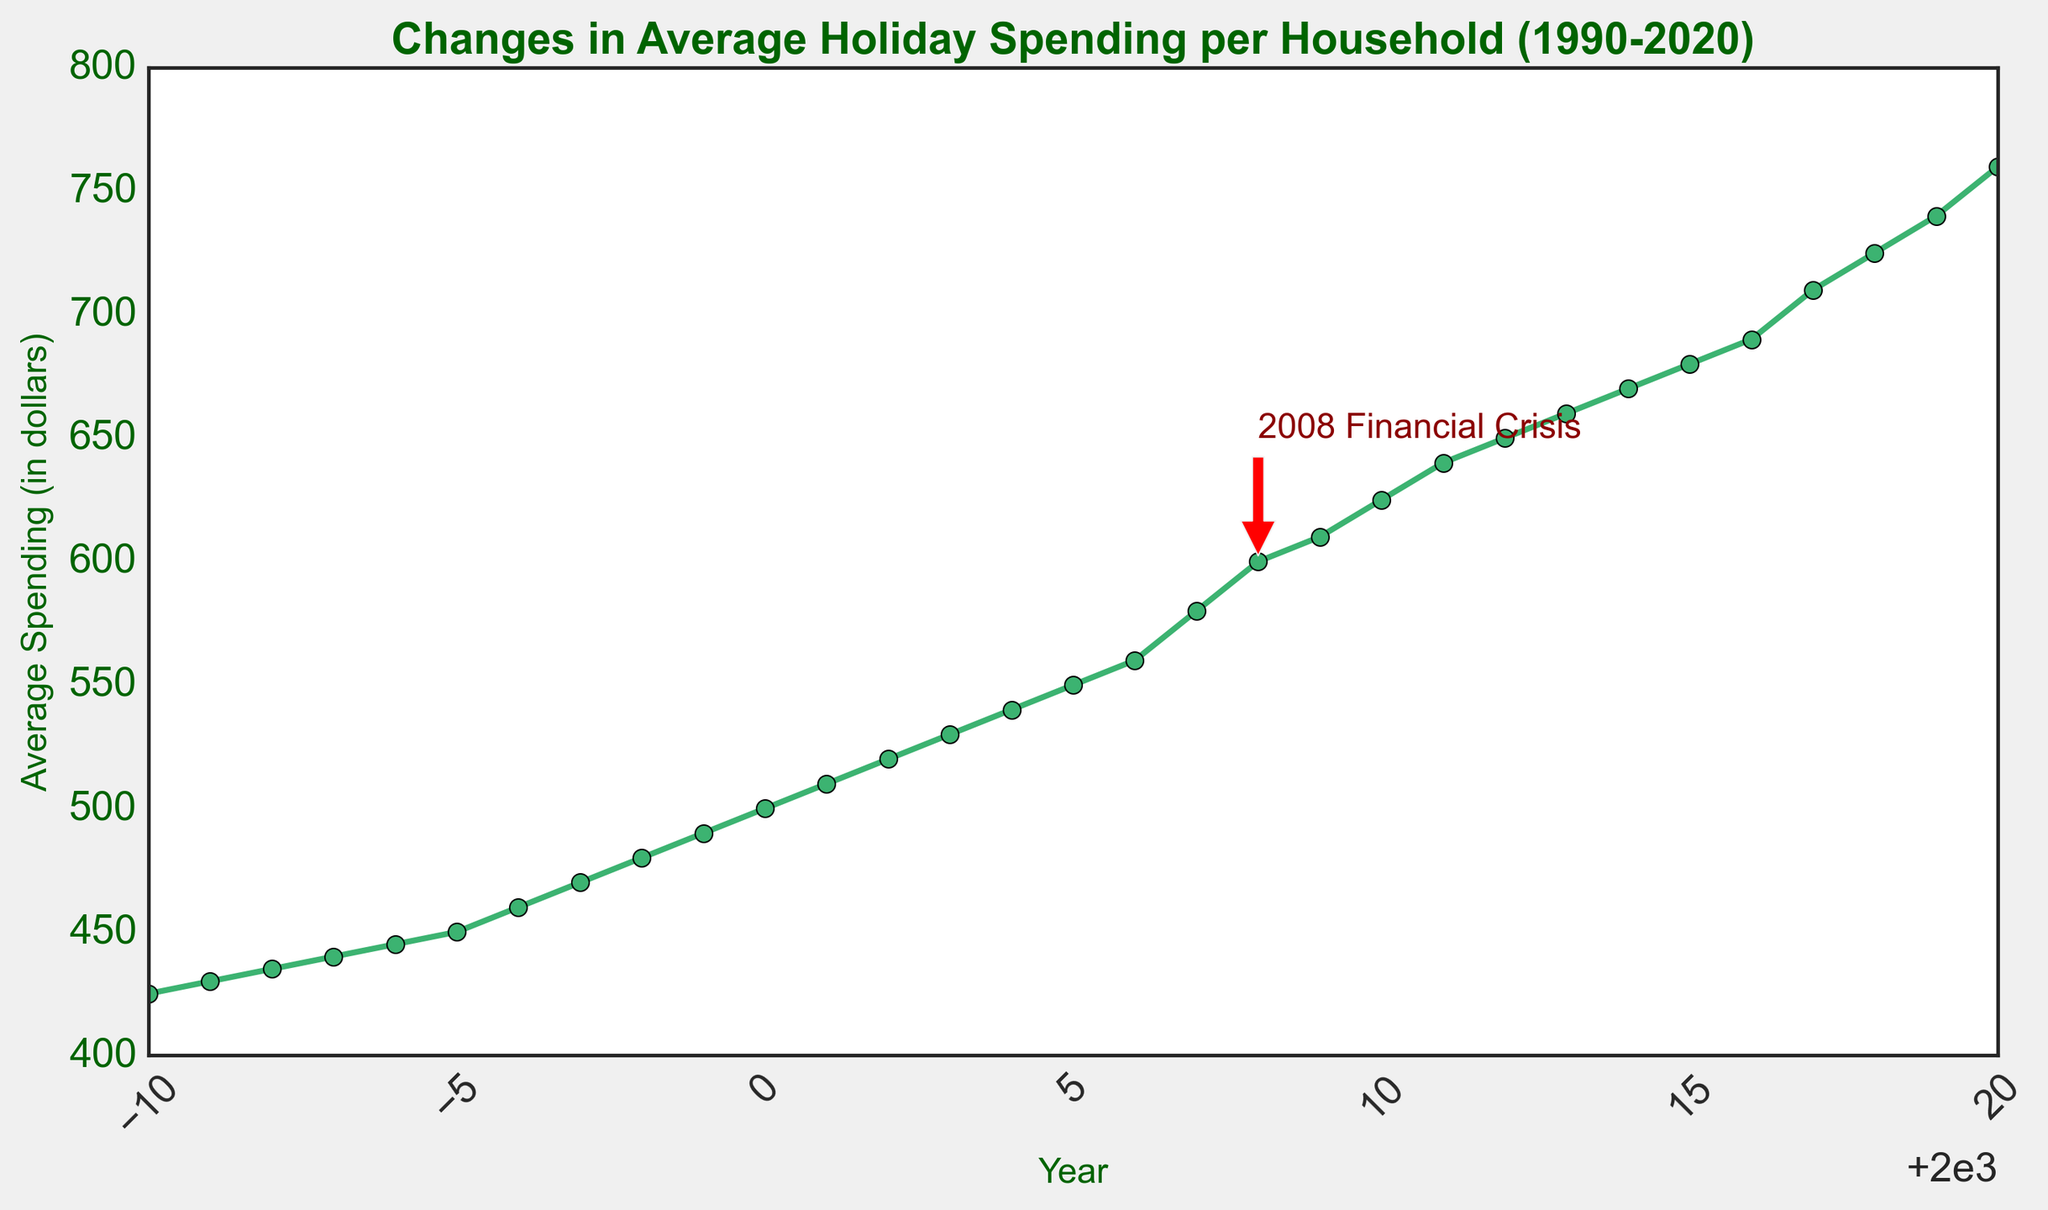What's the average holiday spending in 2000? Referring to the plot, the average holiday spending in the year 2000 is denoted by the data point on the y-axis aligned with 2000 on the x-axis. Looking at this point, the average spending is $500.
Answer: $500 Which year had higher average holiday spending: 2005 or 1995? By comparing the y-values corresponding to the years 2005 and 1995, the plot shows that in 2005 the average spending is $550, while in 1995 it is $450. Hence, 2005 had higher spending.
Answer: 2005 What significant event is annotated in the plot and in which year did it occur? The annotation on the plot points to 2008, indicating "2008 Financial Crisis." This event is highlighted with an arrow pointing to the spending data of that year.
Answer: 2008 Financial Crisis How much did the average holiday spending increase from 1990 to 2020? The plot shows the average holiday spending of $425 in 1990 and $760 in 2020. The increase can be calculated as $760 - $425 = $335.
Answer: $335 What's the average increase in holiday spending per year from 1990 to 2000? The spending in 1990 is $425, and in 2000, it is $500. The total increase over these 10 years is $500 - $425 = $75. The average yearly increase is $75 / 10 = $7.5.
Answer: $7.5 What is the trend of the average holiday spending from 2000 to 2010? Referring to the plot, we observe a continuous increase in the average holiday spending from 2000, starting at $500, to 2010, reaching $625. Thus, the trend is consistently upward.
Answer: Upward trend What's the difference in average holiday spending between 2010 and 2020? On the figure, the average spending is $625 in 2010 and $760 in 2020. The difference is calculated as $760 - $625 = $135.
Answer: $135 Does the plot indicate a continuous increase in holiday spending every year? Studying the plot, we see that the average holiday spending per household increases every year without any downturn or stagnation. Therefore, it indicates a continuous increase.
Answer: Yes By how much did the average holiday spending increase from 2008 to 2009, and is it more or less than the increase from 2009 to 2010? The spending in 2008 is $600 and in 2009 is $610, giving an increase of $10. From 2009 to 2010, the increase is $625 - $610 = $15. Hence, the increase from 2009 to 2010 is more by $5.
Answer: Yes, it's more by $5 What is the color of the annotation arrow on the plot? By looking at the visual attributes in the plot, the annotation indicating "2008 Financial Crisis" is highlighted with an arrow colored in red.
Answer: Red 